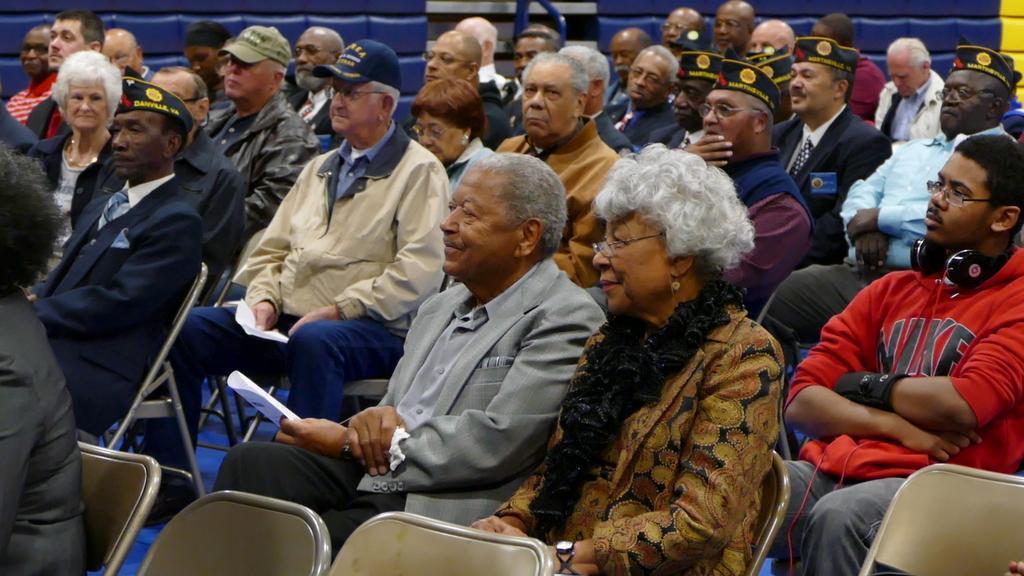In one or two sentences, can you explain what this image depicts? In this image there are group of people who are sitting and some of them are holding some papers and in the background there is a wall. 